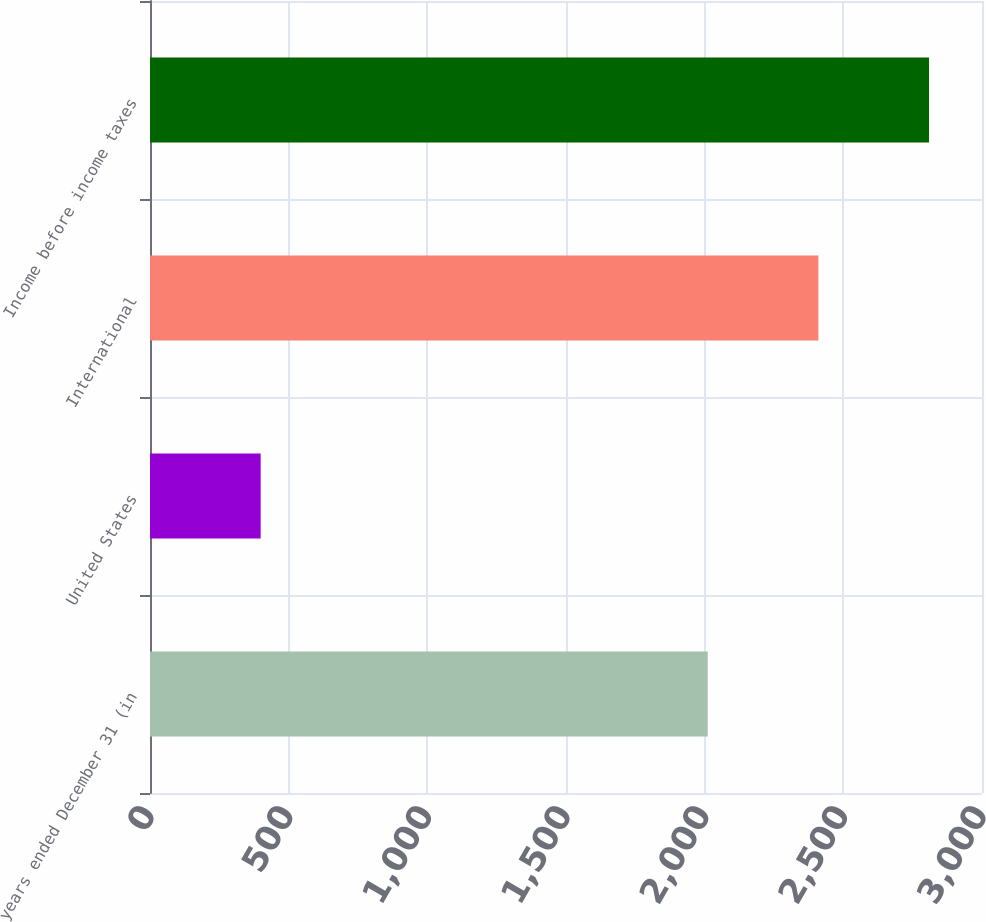Convert chart to OTSL. <chart><loc_0><loc_0><loc_500><loc_500><bar_chart><fcel>years ended December 31 (in<fcel>United States<fcel>International<fcel>Income before income taxes<nl><fcel>2011<fcel>399<fcel>2410<fcel>2809<nl></chart> 